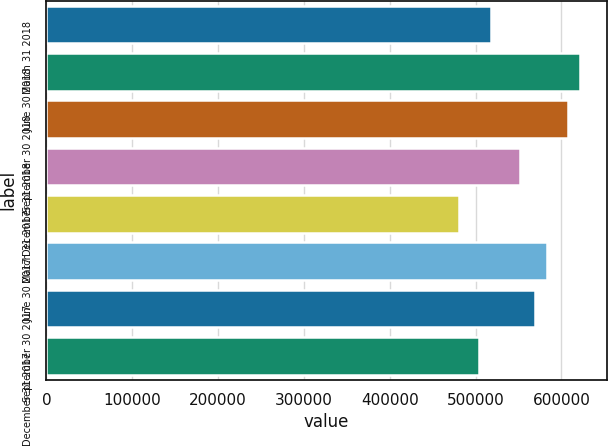Convert chart. <chart><loc_0><loc_0><loc_500><loc_500><bar_chart><fcel>March 31 2018<fcel>June 30 2018<fcel>September 30 2018<fcel>December 31 2018<fcel>March 31 2017<fcel>June 30 2017<fcel>September 30 2017<fcel>December 31 2017<nl><fcel>517548<fcel>621597<fcel>607659<fcel>552201<fcel>480874<fcel>583647<fcel>569709<fcel>503610<nl></chart> 